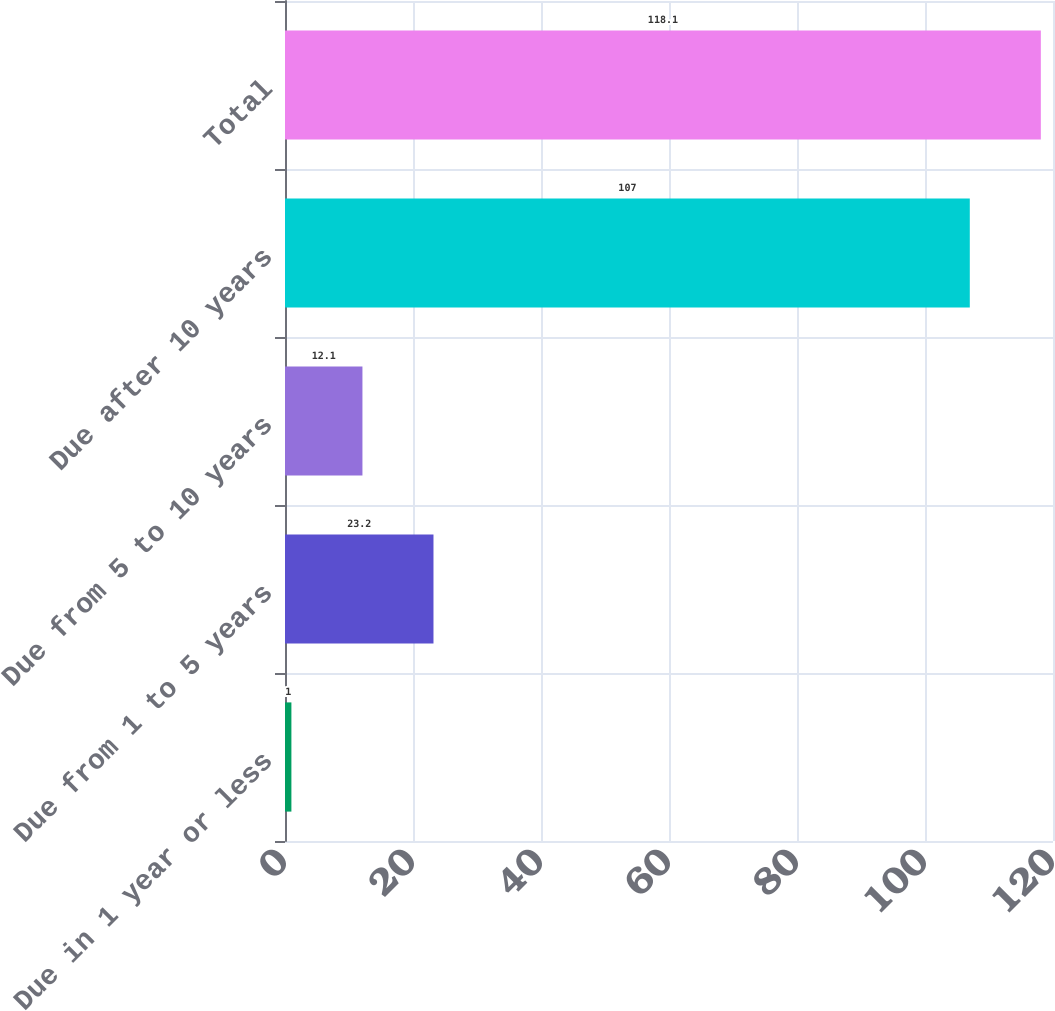<chart> <loc_0><loc_0><loc_500><loc_500><bar_chart><fcel>Due in 1 year or less<fcel>Due from 1 to 5 years<fcel>Due from 5 to 10 years<fcel>Due after 10 years<fcel>Total<nl><fcel>1<fcel>23.2<fcel>12.1<fcel>107<fcel>118.1<nl></chart> 